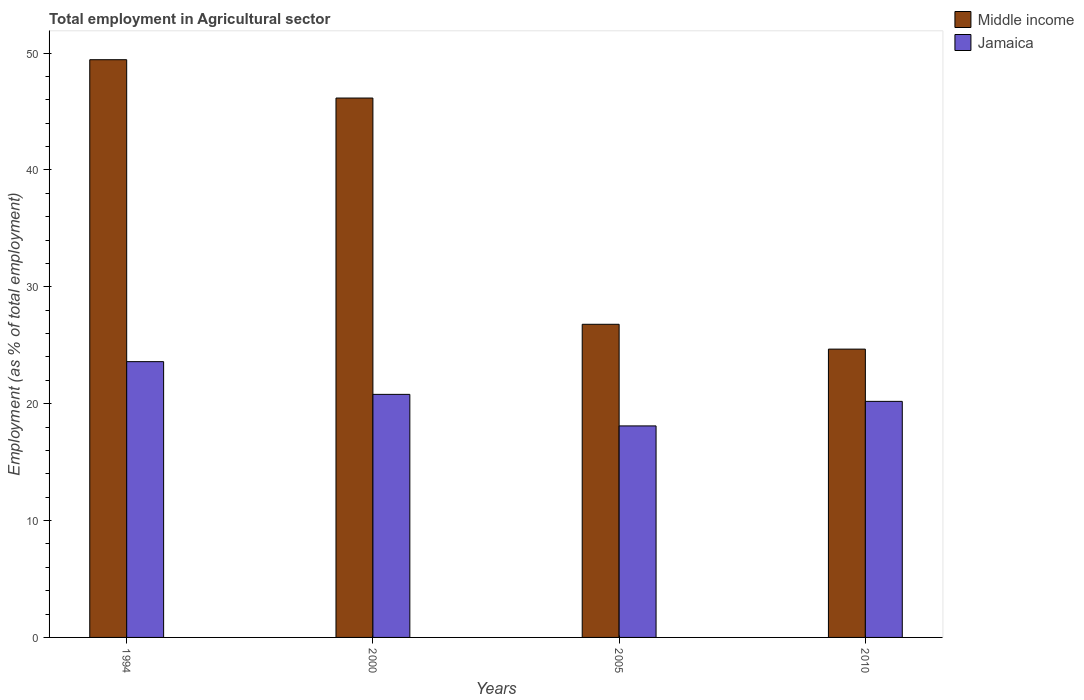How many bars are there on the 4th tick from the right?
Your response must be concise. 2. What is the employment in agricultural sector in Jamaica in 1994?
Keep it short and to the point. 23.6. Across all years, what is the maximum employment in agricultural sector in Middle income?
Your answer should be very brief. 49.44. Across all years, what is the minimum employment in agricultural sector in Jamaica?
Your answer should be compact. 18.1. What is the total employment in agricultural sector in Middle income in the graph?
Keep it short and to the point. 147.06. What is the difference between the employment in agricultural sector in Middle income in 1994 and that in 2010?
Your answer should be very brief. 24.77. What is the difference between the employment in agricultural sector in Jamaica in 2000 and the employment in agricultural sector in Middle income in 2010?
Provide a succinct answer. -3.87. What is the average employment in agricultural sector in Middle income per year?
Provide a short and direct response. 36.77. In the year 2005, what is the difference between the employment in agricultural sector in Middle income and employment in agricultural sector in Jamaica?
Keep it short and to the point. 8.7. In how many years, is the employment in agricultural sector in Jamaica greater than 38 %?
Give a very brief answer. 0. What is the ratio of the employment in agricultural sector in Middle income in 2000 to that in 2010?
Your response must be concise. 1.87. What is the difference between the highest and the second highest employment in agricultural sector in Middle income?
Provide a short and direct response. 3.28. What is the difference between the highest and the lowest employment in agricultural sector in Jamaica?
Offer a terse response. 5.5. What does the 2nd bar from the left in 2000 represents?
Offer a very short reply. Jamaica. What does the 1st bar from the right in 2005 represents?
Your answer should be compact. Jamaica. How many bars are there?
Provide a succinct answer. 8. Are all the bars in the graph horizontal?
Provide a succinct answer. No. Are the values on the major ticks of Y-axis written in scientific E-notation?
Make the answer very short. No. Does the graph contain any zero values?
Make the answer very short. No. Does the graph contain grids?
Keep it short and to the point. No. Where does the legend appear in the graph?
Give a very brief answer. Top right. What is the title of the graph?
Provide a succinct answer. Total employment in Agricultural sector. Does "Singapore" appear as one of the legend labels in the graph?
Provide a short and direct response. No. What is the label or title of the Y-axis?
Ensure brevity in your answer.  Employment (as % of total employment). What is the Employment (as % of total employment) in Middle income in 1994?
Your answer should be very brief. 49.44. What is the Employment (as % of total employment) in Jamaica in 1994?
Your response must be concise. 23.6. What is the Employment (as % of total employment) in Middle income in 2000?
Your answer should be very brief. 46.16. What is the Employment (as % of total employment) of Jamaica in 2000?
Ensure brevity in your answer.  20.8. What is the Employment (as % of total employment) in Middle income in 2005?
Provide a short and direct response. 26.8. What is the Employment (as % of total employment) in Jamaica in 2005?
Your response must be concise. 18.1. What is the Employment (as % of total employment) in Middle income in 2010?
Your answer should be very brief. 24.67. What is the Employment (as % of total employment) of Jamaica in 2010?
Your answer should be very brief. 20.2. Across all years, what is the maximum Employment (as % of total employment) in Middle income?
Your answer should be very brief. 49.44. Across all years, what is the maximum Employment (as % of total employment) of Jamaica?
Your answer should be compact. 23.6. Across all years, what is the minimum Employment (as % of total employment) in Middle income?
Offer a very short reply. 24.67. Across all years, what is the minimum Employment (as % of total employment) in Jamaica?
Offer a terse response. 18.1. What is the total Employment (as % of total employment) in Middle income in the graph?
Make the answer very short. 147.06. What is the total Employment (as % of total employment) of Jamaica in the graph?
Your response must be concise. 82.7. What is the difference between the Employment (as % of total employment) of Middle income in 1994 and that in 2000?
Your response must be concise. 3.28. What is the difference between the Employment (as % of total employment) of Middle income in 1994 and that in 2005?
Your answer should be very brief. 22.64. What is the difference between the Employment (as % of total employment) in Middle income in 1994 and that in 2010?
Give a very brief answer. 24.77. What is the difference between the Employment (as % of total employment) in Middle income in 2000 and that in 2005?
Offer a very short reply. 19.36. What is the difference between the Employment (as % of total employment) of Middle income in 2000 and that in 2010?
Ensure brevity in your answer.  21.49. What is the difference between the Employment (as % of total employment) in Jamaica in 2000 and that in 2010?
Provide a short and direct response. 0.6. What is the difference between the Employment (as % of total employment) of Middle income in 2005 and that in 2010?
Provide a short and direct response. 2.12. What is the difference between the Employment (as % of total employment) in Jamaica in 2005 and that in 2010?
Offer a very short reply. -2.1. What is the difference between the Employment (as % of total employment) of Middle income in 1994 and the Employment (as % of total employment) of Jamaica in 2000?
Your answer should be compact. 28.64. What is the difference between the Employment (as % of total employment) in Middle income in 1994 and the Employment (as % of total employment) in Jamaica in 2005?
Offer a terse response. 31.34. What is the difference between the Employment (as % of total employment) of Middle income in 1994 and the Employment (as % of total employment) of Jamaica in 2010?
Your answer should be very brief. 29.24. What is the difference between the Employment (as % of total employment) of Middle income in 2000 and the Employment (as % of total employment) of Jamaica in 2005?
Keep it short and to the point. 28.06. What is the difference between the Employment (as % of total employment) in Middle income in 2000 and the Employment (as % of total employment) in Jamaica in 2010?
Provide a short and direct response. 25.96. What is the difference between the Employment (as % of total employment) of Middle income in 2005 and the Employment (as % of total employment) of Jamaica in 2010?
Give a very brief answer. 6.6. What is the average Employment (as % of total employment) in Middle income per year?
Your answer should be compact. 36.77. What is the average Employment (as % of total employment) of Jamaica per year?
Your answer should be compact. 20.68. In the year 1994, what is the difference between the Employment (as % of total employment) of Middle income and Employment (as % of total employment) of Jamaica?
Provide a short and direct response. 25.84. In the year 2000, what is the difference between the Employment (as % of total employment) of Middle income and Employment (as % of total employment) of Jamaica?
Give a very brief answer. 25.36. In the year 2005, what is the difference between the Employment (as % of total employment) of Middle income and Employment (as % of total employment) of Jamaica?
Your answer should be very brief. 8.7. In the year 2010, what is the difference between the Employment (as % of total employment) in Middle income and Employment (as % of total employment) in Jamaica?
Your answer should be compact. 4.47. What is the ratio of the Employment (as % of total employment) of Middle income in 1994 to that in 2000?
Give a very brief answer. 1.07. What is the ratio of the Employment (as % of total employment) of Jamaica in 1994 to that in 2000?
Keep it short and to the point. 1.13. What is the ratio of the Employment (as % of total employment) in Middle income in 1994 to that in 2005?
Provide a short and direct response. 1.84. What is the ratio of the Employment (as % of total employment) of Jamaica in 1994 to that in 2005?
Ensure brevity in your answer.  1.3. What is the ratio of the Employment (as % of total employment) of Middle income in 1994 to that in 2010?
Your answer should be compact. 2. What is the ratio of the Employment (as % of total employment) in Jamaica in 1994 to that in 2010?
Provide a short and direct response. 1.17. What is the ratio of the Employment (as % of total employment) of Middle income in 2000 to that in 2005?
Your answer should be compact. 1.72. What is the ratio of the Employment (as % of total employment) of Jamaica in 2000 to that in 2005?
Your answer should be compact. 1.15. What is the ratio of the Employment (as % of total employment) in Middle income in 2000 to that in 2010?
Provide a succinct answer. 1.87. What is the ratio of the Employment (as % of total employment) in Jamaica in 2000 to that in 2010?
Offer a very short reply. 1.03. What is the ratio of the Employment (as % of total employment) in Middle income in 2005 to that in 2010?
Provide a succinct answer. 1.09. What is the ratio of the Employment (as % of total employment) in Jamaica in 2005 to that in 2010?
Provide a short and direct response. 0.9. What is the difference between the highest and the second highest Employment (as % of total employment) in Middle income?
Your answer should be compact. 3.28. What is the difference between the highest and the lowest Employment (as % of total employment) in Middle income?
Your response must be concise. 24.77. 